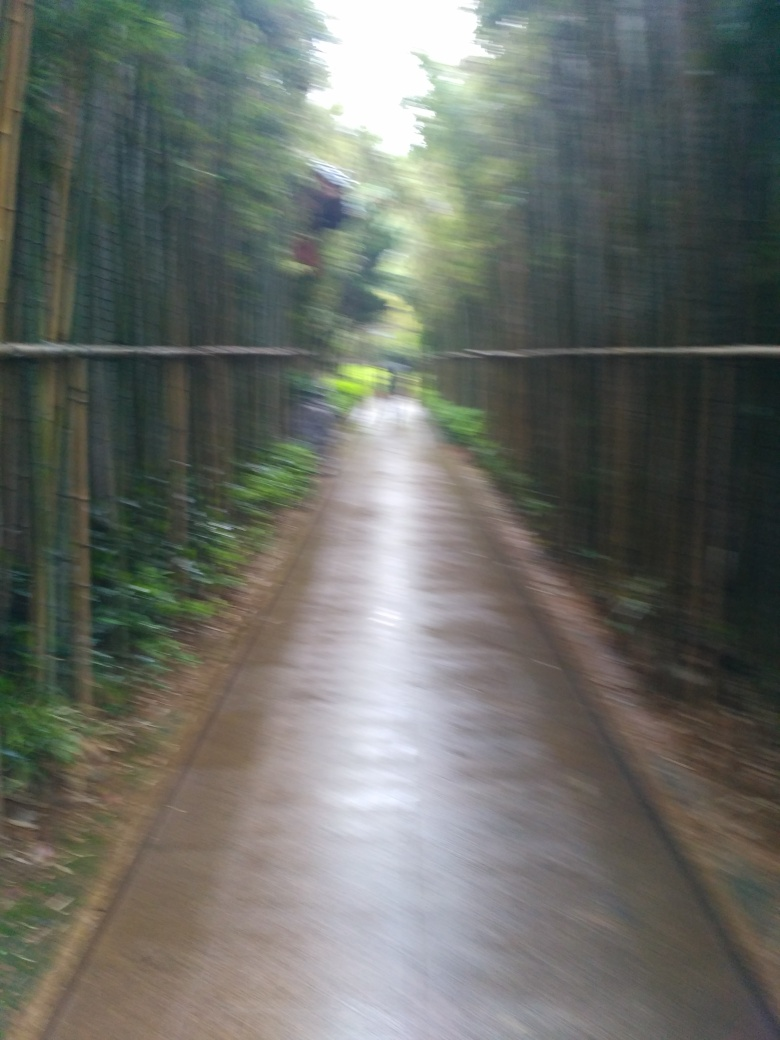This path seems quite peaceful. Can you tell what time of day this photo might have been taken? While the exact time is difficult to infer without direct clues, such as the position of sun or shadows, the lighting seems soft and not too harsh, suggesting that it could be a photo taken in the early morning or late afternoon, when the light is gentler. 